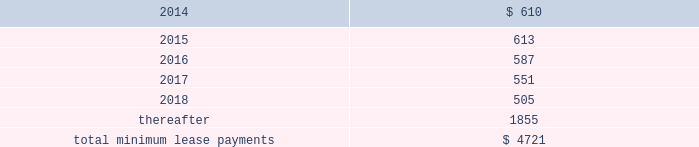Table of contents rent expense under all operating leases , including both cancelable and noncancelable leases , was $ 645 million , $ 488 million and $ 338 million in 2013 , 2012 and 2011 , respectively .
Future minimum lease payments under noncancelable operating leases having remaining terms in excess of one year as of september 28 , 2013 , are as follows ( in millions ) : other commitments as of september 28 , 2013 , the company had outstanding off-balance sheet third-party manufacturing commitments and component purchase commitments of $ 18.6 billion .
In addition to the off-balance sheet commitments mentioned above , the company had outstanding obligations of $ 1.3 billion as of september 28 , 2013 , which consisted mainly of commitments to acquire capital assets , including product tooling and manufacturing process equipment , and commitments related to advertising , research and development , internet and telecommunications services and other obligations .
Contingencies the company is subject to various legal proceedings and claims that have arisen in the ordinary course of business and that have not been fully adjudicated .
In the opinion of management , there was not at least a reasonable possibility the company may have incurred a material loss , or a material loss in excess of a recorded accrual , with respect to loss contingencies .
However , the outcome of litigation is inherently uncertain .
Therefore , although management considers the likelihood of such an outcome to be remote , if one or more of these legal matters were resolved against the company in a reporting period for amounts in excess of management 2019s expectations , the company 2019s consolidated financial statements for that reporting period could be materially adversely affected .
Apple inc .
Samsung electronics co. , ltd , et al .
On august 24 , 2012 , a jury returned a verdict awarding the company $ 1.05 billion in its lawsuit against samsung electronics co. , ltd and affiliated parties in the united states district court , northern district of california , san jose division .
On march 1 , 2013 , the district court upheld $ 599 million of the jury 2019s award and ordered a new trial as to the remainder .
Because the award is subject to entry of final judgment , partial re-trial and appeal , the company has not recognized the award in its results of operations .
Virnetx , inc .
Apple inc .
Et al .
On august 11 , 2010 , virnetx , inc .
Filed an action against the company alleging that certain of its products infringed on four patents relating to network communications technology .
On november 6 , 2012 , a jury returned a verdict against the company , and awarded damages of $ 368 million .
The company is challenging the verdict , believes it has valid defenses and has not recorded a loss accrual at this time. .

Why is the information relative to 2012 costs incorrect and what would the correct information be? 
Rationale: apple has not taken the losses for the virnet.inc lawsuit because it requested a retrial . this means that the lease expensive for that year are incorrect and should be 856 million .
Computations: (488 + 368)
Answer: 856.0. 